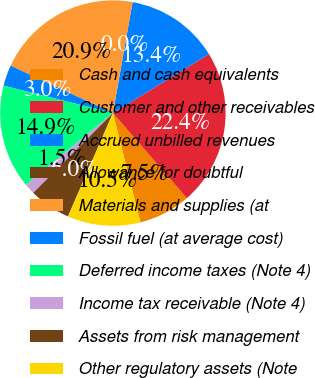<chart> <loc_0><loc_0><loc_500><loc_500><pie_chart><fcel>Cash and cash equivalents<fcel>Customer and other receivables<fcel>Accrued unbilled revenues<fcel>Allowance for doubtful<fcel>Materials and supplies (at<fcel>Fossil fuel (at average cost)<fcel>Deferred income taxes (Note 4)<fcel>Income tax receivable (Note 4)<fcel>Assets from risk management<fcel>Other regulatory assets (Note<nl><fcel>7.46%<fcel>22.38%<fcel>13.43%<fcel>0.0%<fcel>20.89%<fcel>2.99%<fcel>14.92%<fcel>1.5%<fcel>5.97%<fcel>10.45%<nl></chart> 